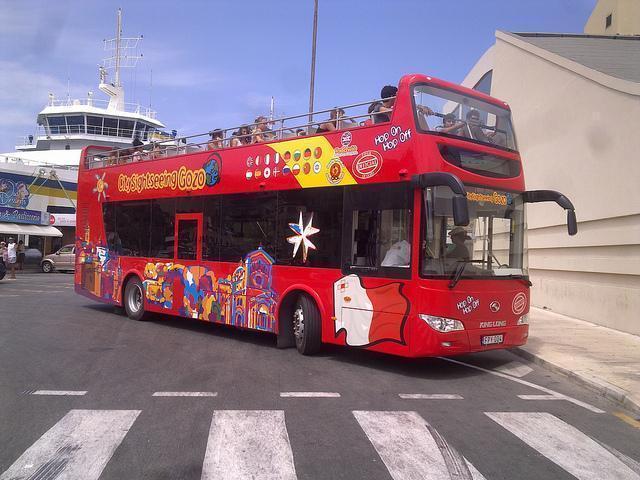What is the name for this type of vehicle?
Select the correct answer and articulate reasoning with the following format: 'Answer: answer
Rationale: rationale.'
Options: School, articulated, double decker, off road. Answer: double decker.
Rationale: There are two decks to the bus. 